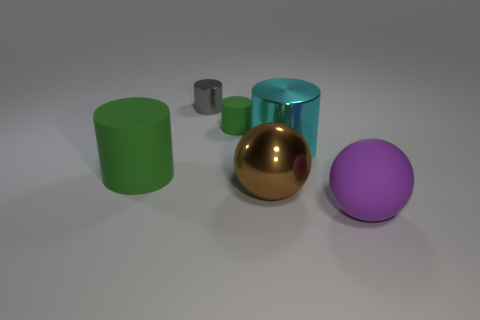What number of other things are there of the same size as the gray cylinder?
Make the answer very short. 1. What is the material of the purple sphere?
Make the answer very short. Rubber. Is the number of purple spheres right of the brown ball greater than the number of tiny blue matte cubes?
Make the answer very short. Yes. Are there any gray shiny cylinders?
Provide a short and direct response. Yes. How many other things are there of the same shape as the gray object?
Offer a very short reply. 3. Does the metal cylinder behind the tiny green cylinder have the same color as the ball that is in front of the big metallic sphere?
Provide a short and direct response. No. What is the size of the green object that is to the right of the green cylinder that is left of the green matte cylinder on the right side of the big green cylinder?
Offer a terse response. Small. There is a rubber object that is to the right of the small metallic cylinder and on the left side of the purple rubber object; what is its shape?
Offer a terse response. Cylinder. Are there an equal number of large brown metallic spheres behind the large cyan shiny thing and big brown things that are to the right of the purple object?
Offer a very short reply. Yes. Are there any small gray cylinders that have the same material as the big purple thing?
Ensure brevity in your answer.  No. 